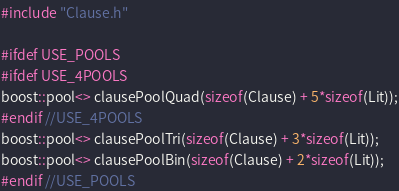<code> <loc_0><loc_0><loc_500><loc_500><_C++_>#include "Clause.h"

#ifdef USE_POOLS
#ifdef USE_4POOLS
boost::pool<> clausePoolQuad(sizeof(Clause) + 5*sizeof(Lit));
#endif //USE_4POOLS
boost::pool<> clausePoolTri(sizeof(Clause) + 3*sizeof(Lit));
boost::pool<> clausePoolBin(sizeof(Clause) + 2*sizeof(Lit));
#endif //USE_POOLS
</code> 